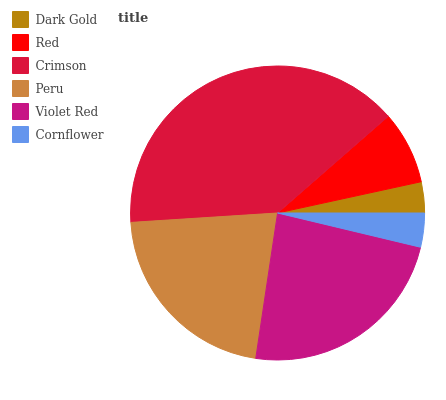Is Dark Gold the minimum?
Answer yes or no. Yes. Is Crimson the maximum?
Answer yes or no. Yes. Is Red the minimum?
Answer yes or no. No. Is Red the maximum?
Answer yes or no. No. Is Red greater than Dark Gold?
Answer yes or no. Yes. Is Dark Gold less than Red?
Answer yes or no. Yes. Is Dark Gold greater than Red?
Answer yes or no. No. Is Red less than Dark Gold?
Answer yes or no. No. Is Peru the high median?
Answer yes or no. Yes. Is Red the low median?
Answer yes or no. Yes. Is Cornflower the high median?
Answer yes or no. No. Is Violet Red the low median?
Answer yes or no. No. 